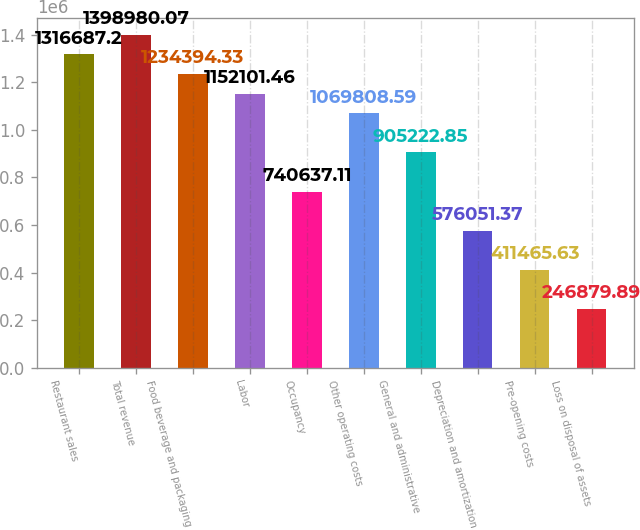<chart> <loc_0><loc_0><loc_500><loc_500><bar_chart><fcel>Restaurant sales<fcel>Total revenue<fcel>Food beverage and packaging<fcel>Labor<fcel>Occupancy<fcel>Other operating costs<fcel>General and administrative<fcel>Depreciation and amortization<fcel>Pre-opening costs<fcel>Loss on disposal of assets<nl><fcel>1.31669e+06<fcel>1.39898e+06<fcel>1.23439e+06<fcel>1.1521e+06<fcel>740637<fcel>1.06981e+06<fcel>905223<fcel>576051<fcel>411466<fcel>246880<nl></chart> 